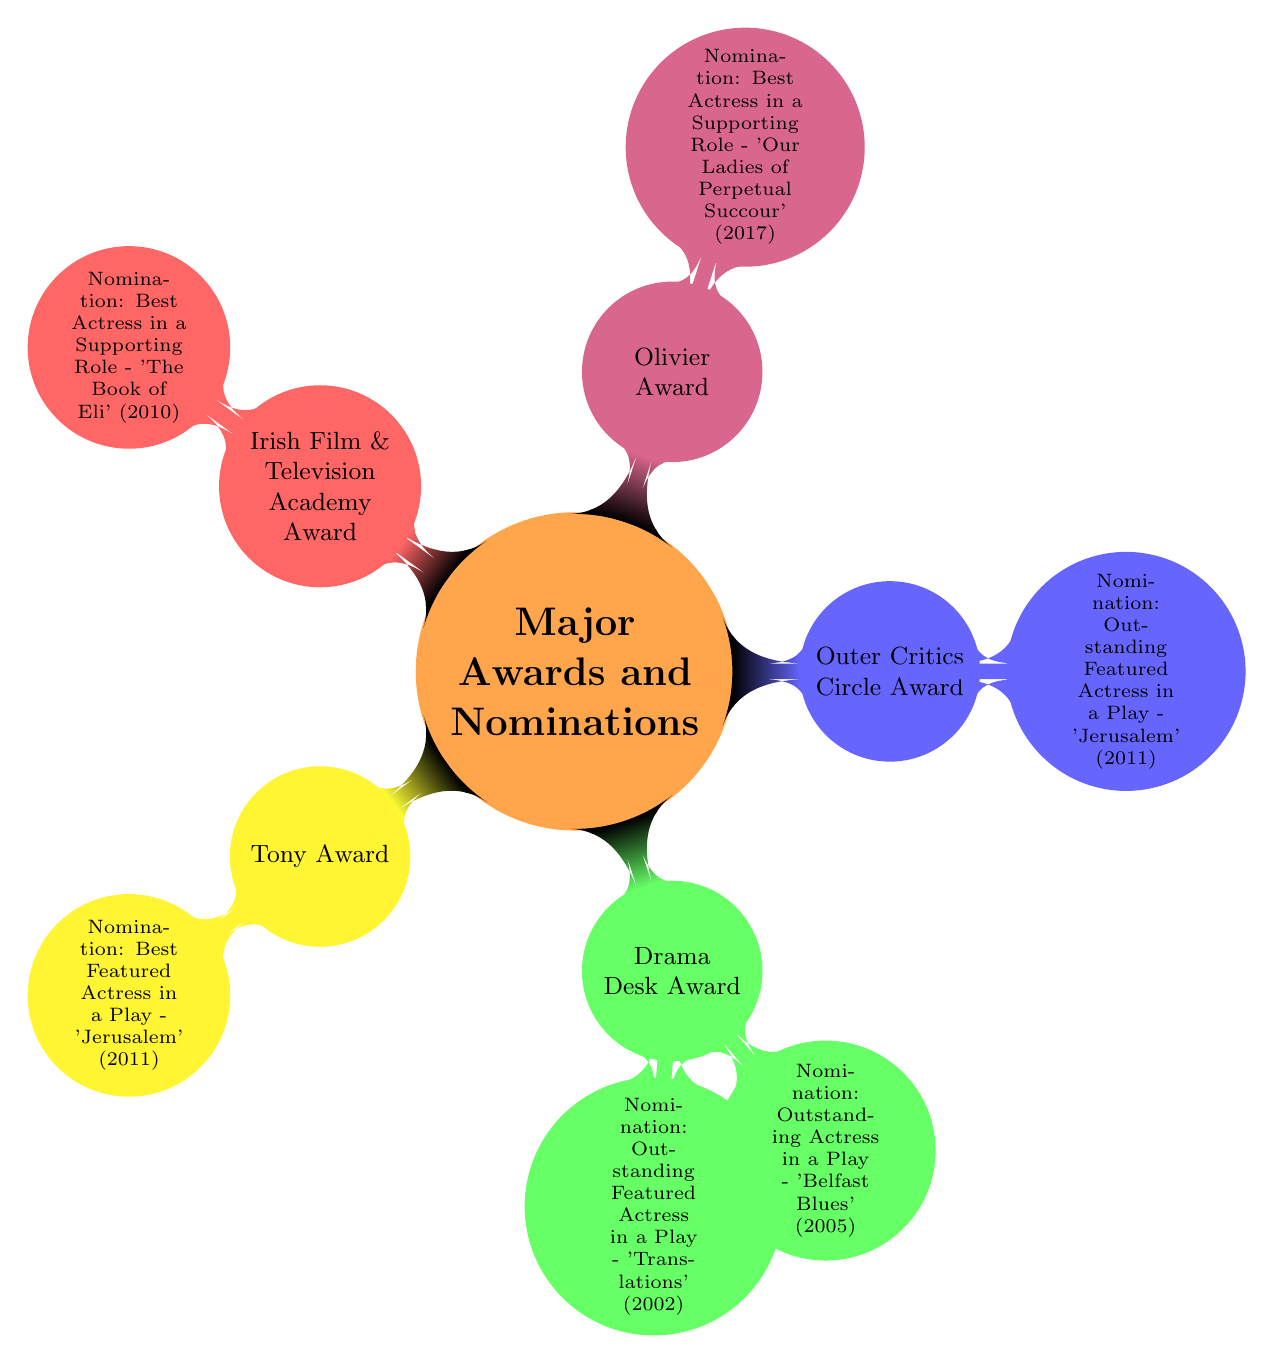What is the only award for which Geraldine Hughes received a nomination in 2011? The diagram shows two awards associated with the year 2011: the Tony Award and the Outer Critics Circle Award. Both have the same nomination, which is "Best Featured Actress in a Play - 'Jerusalem' (2011)." Therefore, the award for which she received a nomination in 2011 is both, but since the question asks for one, I will refer to either, consistently reflected in the diagram.
Answer: Outer Critics Circle Award How many nominations did Geraldine Hughes receive for the Drama Desk Award? According to the diagram, the Drama Desk Award has two nominations listed: "Outstanding Featured Actress in a Play - 'Translations' (2002)" and "Outstanding Actress in a Play - 'Belfast Blues' (2005)." Hence, the total number of nominations is two.
Answer: 2 What role was nominated for the Olivier Award? Looking at the column for the Olivier Award, it lists one nomination: "Best Actress in a Supporting Role - 'Our Ladies of Perpetual Succour' (2017)." The role related to this nomination is in that play.
Answer: Our Ladies of Perpetual Succour Which award had a nomination specifically for Best Actress in a Supporting Role? The diagram identifies two awards with nominations for Best Actress in a Supporting Role: the Olivier Award ("Best Actress in a Supporting Role - 'Our Ladies of Perpetual Succour' (2017)") and the Irish Film & Television Academy Award ("Best Actress in a Supporting Role - 'The Book of Eli' (2010)"). Therefore, the answer includes both awards that meet the specific nomination criteria.
Answer: Olivier Award, Irish Film & Television Academy Award How many total awards does the diagram mention for Geraldine Hughes? To find the total number of awards, count the distinct awards listed: Tony Award, Drama Desk Award, Outer Critics Circle Award, Olivier Award, and Irish Film & Television Academy Award. This gives a total of five awards.
Answer: 5 